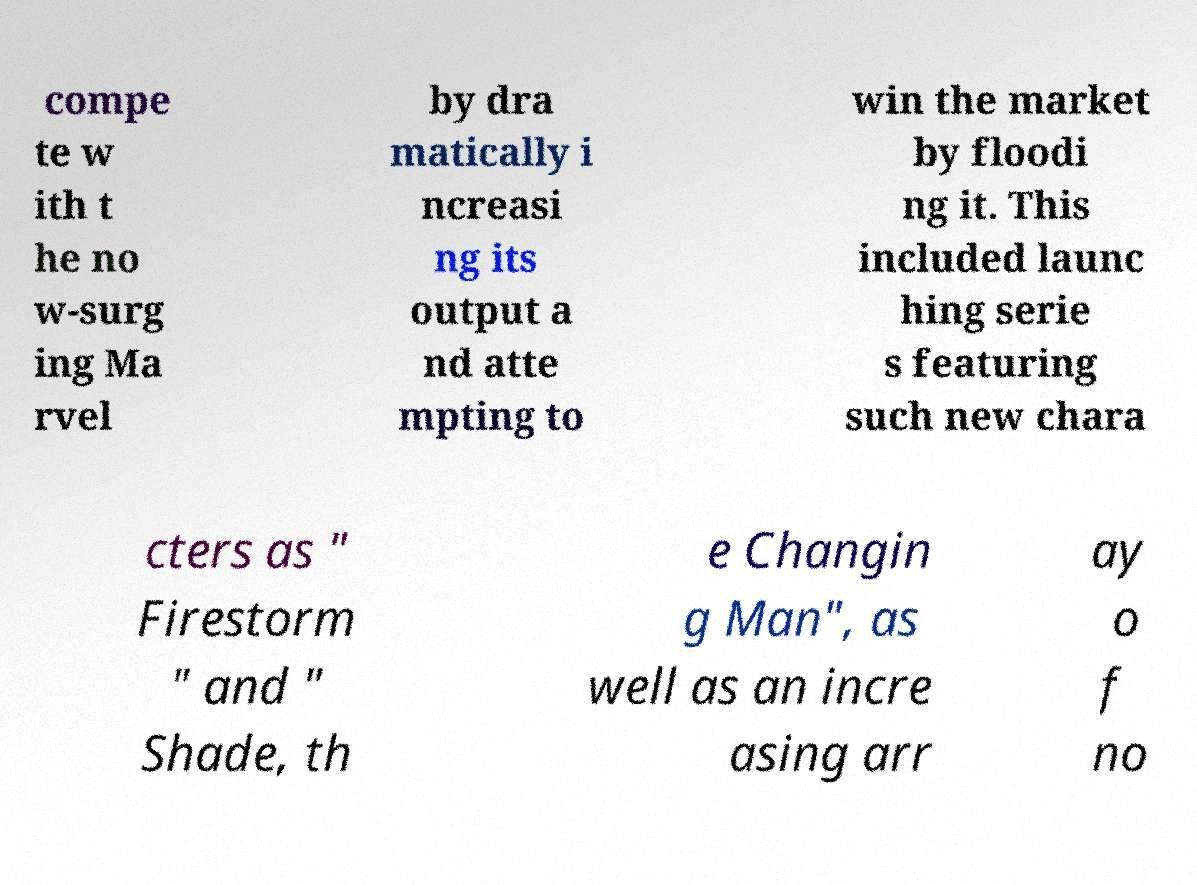There's text embedded in this image that I need extracted. Can you transcribe it verbatim? compe te w ith t he no w-surg ing Ma rvel by dra matically i ncreasi ng its output a nd atte mpting to win the market by floodi ng it. This included launc hing serie s featuring such new chara cters as " Firestorm " and " Shade, th e Changin g Man", as well as an incre asing arr ay o f no 